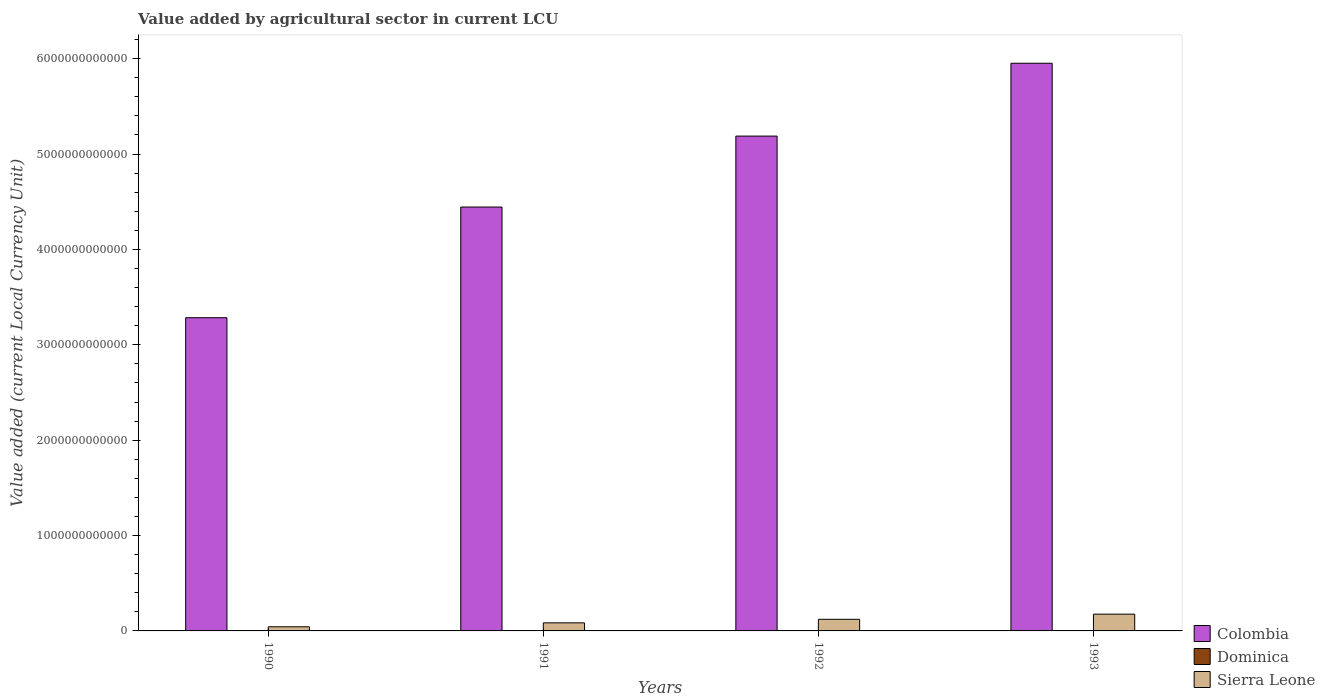How many different coloured bars are there?
Offer a terse response. 3. How many groups of bars are there?
Provide a succinct answer. 4. Are the number of bars per tick equal to the number of legend labels?
Keep it short and to the point. Yes. Are the number of bars on each tick of the X-axis equal?
Provide a short and direct response. Yes. What is the value added by agricultural sector in Sierra Leone in 1993?
Your response must be concise. 1.76e+11. Across all years, what is the maximum value added by agricultural sector in Dominica?
Provide a short and direct response. 9.80e+07. Across all years, what is the minimum value added by agricultural sector in Dominica?
Provide a short and direct response. 9.25e+07. In which year was the value added by agricultural sector in Sierra Leone minimum?
Your answer should be very brief. 1990. What is the total value added by agricultural sector in Colombia in the graph?
Provide a short and direct response. 1.89e+13. What is the difference between the value added by agricultural sector in Colombia in 1990 and that in 1992?
Provide a succinct answer. -1.90e+12. What is the difference between the value added by agricultural sector in Sierra Leone in 1993 and the value added by agricultural sector in Dominica in 1990?
Offer a terse response. 1.76e+11. What is the average value added by agricultural sector in Sierra Leone per year?
Make the answer very short. 1.06e+11. In the year 1991, what is the difference between the value added by agricultural sector in Colombia and value added by agricultural sector in Sierra Leone?
Provide a short and direct response. 4.36e+12. What is the ratio of the value added by agricultural sector in Dominica in 1991 to that in 1993?
Your response must be concise. 0.99. What is the difference between the highest and the lowest value added by agricultural sector in Sierra Leone?
Give a very brief answer. 1.33e+11. What does the 2nd bar from the left in 1990 represents?
Ensure brevity in your answer.  Dominica. What does the 1st bar from the right in 1990 represents?
Offer a terse response. Sierra Leone. How many bars are there?
Keep it short and to the point. 12. Are all the bars in the graph horizontal?
Offer a terse response. No. What is the difference between two consecutive major ticks on the Y-axis?
Offer a terse response. 1.00e+12. Are the values on the major ticks of Y-axis written in scientific E-notation?
Make the answer very short. No. Does the graph contain any zero values?
Offer a terse response. No. Does the graph contain grids?
Ensure brevity in your answer.  No. Where does the legend appear in the graph?
Make the answer very short. Bottom right. How many legend labels are there?
Ensure brevity in your answer.  3. How are the legend labels stacked?
Make the answer very short. Vertical. What is the title of the graph?
Keep it short and to the point. Value added by agricultural sector in current LCU. Does "Malaysia" appear as one of the legend labels in the graph?
Provide a short and direct response. No. What is the label or title of the Y-axis?
Offer a very short reply. Value added (current Local Currency Unit). What is the Value added (current Local Currency Unit) in Colombia in 1990?
Provide a short and direct response. 3.28e+12. What is the Value added (current Local Currency Unit) in Dominica in 1990?
Keep it short and to the point. 9.25e+07. What is the Value added (current Local Currency Unit) in Sierra Leone in 1990?
Give a very brief answer. 4.33e+1. What is the Value added (current Local Currency Unit) of Colombia in 1991?
Your answer should be compact. 4.44e+12. What is the Value added (current Local Currency Unit) of Dominica in 1991?
Provide a short and direct response. 9.69e+07. What is the Value added (current Local Currency Unit) in Sierra Leone in 1991?
Make the answer very short. 8.46e+1. What is the Value added (current Local Currency Unit) in Colombia in 1992?
Your answer should be very brief. 5.19e+12. What is the Value added (current Local Currency Unit) of Dominica in 1992?
Your answer should be very brief. 9.76e+07. What is the Value added (current Local Currency Unit) of Sierra Leone in 1992?
Provide a short and direct response. 1.22e+11. What is the Value added (current Local Currency Unit) in Colombia in 1993?
Offer a very short reply. 5.95e+12. What is the Value added (current Local Currency Unit) in Dominica in 1993?
Offer a terse response. 9.80e+07. What is the Value added (current Local Currency Unit) of Sierra Leone in 1993?
Provide a short and direct response. 1.76e+11. Across all years, what is the maximum Value added (current Local Currency Unit) of Colombia?
Make the answer very short. 5.95e+12. Across all years, what is the maximum Value added (current Local Currency Unit) of Dominica?
Your response must be concise. 9.80e+07. Across all years, what is the maximum Value added (current Local Currency Unit) in Sierra Leone?
Give a very brief answer. 1.76e+11. Across all years, what is the minimum Value added (current Local Currency Unit) in Colombia?
Make the answer very short. 3.28e+12. Across all years, what is the minimum Value added (current Local Currency Unit) in Dominica?
Keep it short and to the point. 9.25e+07. Across all years, what is the minimum Value added (current Local Currency Unit) in Sierra Leone?
Your answer should be very brief. 4.33e+1. What is the total Value added (current Local Currency Unit) of Colombia in the graph?
Offer a terse response. 1.89e+13. What is the total Value added (current Local Currency Unit) of Dominica in the graph?
Offer a terse response. 3.85e+08. What is the total Value added (current Local Currency Unit) of Sierra Leone in the graph?
Your answer should be compact. 4.26e+11. What is the difference between the Value added (current Local Currency Unit) in Colombia in 1990 and that in 1991?
Make the answer very short. -1.16e+12. What is the difference between the Value added (current Local Currency Unit) in Dominica in 1990 and that in 1991?
Offer a terse response. -4.42e+06. What is the difference between the Value added (current Local Currency Unit) of Sierra Leone in 1990 and that in 1991?
Provide a short and direct response. -4.13e+1. What is the difference between the Value added (current Local Currency Unit) in Colombia in 1990 and that in 1992?
Your answer should be compact. -1.90e+12. What is the difference between the Value added (current Local Currency Unit) in Dominica in 1990 and that in 1992?
Keep it short and to the point. -5.13e+06. What is the difference between the Value added (current Local Currency Unit) in Sierra Leone in 1990 and that in 1992?
Provide a succinct answer. -7.86e+1. What is the difference between the Value added (current Local Currency Unit) in Colombia in 1990 and that in 1993?
Provide a succinct answer. -2.67e+12. What is the difference between the Value added (current Local Currency Unit) in Dominica in 1990 and that in 1993?
Ensure brevity in your answer.  -5.52e+06. What is the difference between the Value added (current Local Currency Unit) in Sierra Leone in 1990 and that in 1993?
Give a very brief answer. -1.33e+11. What is the difference between the Value added (current Local Currency Unit) of Colombia in 1991 and that in 1992?
Keep it short and to the point. -7.44e+11. What is the difference between the Value added (current Local Currency Unit) in Dominica in 1991 and that in 1992?
Your answer should be compact. -7.10e+05. What is the difference between the Value added (current Local Currency Unit) of Sierra Leone in 1991 and that in 1992?
Ensure brevity in your answer.  -3.72e+1. What is the difference between the Value added (current Local Currency Unit) of Colombia in 1991 and that in 1993?
Provide a succinct answer. -1.51e+12. What is the difference between the Value added (current Local Currency Unit) in Dominica in 1991 and that in 1993?
Make the answer very short. -1.10e+06. What is the difference between the Value added (current Local Currency Unit) in Sierra Leone in 1991 and that in 1993?
Ensure brevity in your answer.  -9.12e+1. What is the difference between the Value added (current Local Currency Unit) in Colombia in 1992 and that in 1993?
Offer a very short reply. -7.64e+11. What is the difference between the Value added (current Local Currency Unit) in Dominica in 1992 and that in 1993?
Your answer should be compact. -3.90e+05. What is the difference between the Value added (current Local Currency Unit) in Sierra Leone in 1992 and that in 1993?
Offer a very short reply. -5.40e+1. What is the difference between the Value added (current Local Currency Unit) in Colombia in 1990 and the Value added (current Local Currency Unit) in Dominica in 1991?
Provide a succinct answer. 3.28e+12. What is the difference between the Value added (current Local Currency Unit) of Colombia in 1990 and the Value added (current Local Currency Unit) of Sierra Leone in 1991?
Your response must be concise. 3.20e+12. What is the difference between the Value added (current Local Currency Unit) of Dominica in 1990 and the Value added (current Local Currency Unit) of Sierra Leone in 1991?
Offer a terse response. -8.46e+1. What is the difference between the Value added (current Local Currency Unit) in Colombia in 1990 and the Value added (current Local Currency Unit) in Dominica in 1992?
Keep it short and to the point. 3.28e+12. What is the difference between the Value added (current Local Currency Unit) of Colombia in 1990 and the Value added (current Local Currency Unit) of Sierra Leone in 1992?
Make the answer very short. 3.16e+12. What is the difference between the Value added (current Local Currency Unit) in Dominica in 1990 and the Value added (current Local Currency Unit) in Sierra Leone in 1992?
Provide a short and direct response. -1.22e+11. What is the difference between the Value added (current Local Currency Unit) in Colombia in 1990 and the Value added (current Local Currency Unit) in Dominica in 1993?
Your answer should be very brief. 3.28e+12. What is the difference between the Value added (current Local Currency Unit) of Colombia in 1990 and the Value added (current Local Currency Unit) of Sierra Leone in 1993?
Make the answer very short. 3.11e+12. What is the difference between the Value added (current Local Currency Unit) of Dominica in 1990 and the Value added (current Local Currency Unit) of Sierra Leone in 1993?
Your answer should be very brief. -1.76e+11. What is the difference between the Value added (current Local Currency Unit) of Colombia in 1991 and the Value added (current Local Currency Unit) of Dominica in 1992?
Your answer should be compact. 4.44e+12. What is the difference between the Value added (current Local Currency Unit) in Colombia in 1991 and the Value added (current Local Currency Unit) in Sierra Leone in 1992?
Keep it short and to the point. 4.32e+12. What is the difference between the Value added (current Local Currency Unit) in Dominica in 1991 and the Value added (current Local Currency Unit) in Sierra Leone in 1992?
Your response must be concise. -1.22e+11. What is the difference between the Value added (current Local Currency Unit) of Colombia in 1991 and the Value added (current Local Currency Unit) of Dominica in 1993?
Ensure brevity in your answer.  4.44e+12. What is the difference between the Value added (current Local Currency Unit) in Colombia in 1991 and the Value added (current Local Currency Unit) in Sierra Leone in 1993?
Your answer should be very brief. 4.27e+12. What is the difference between the Value added (current Local Currency Unit) in Dominica in 1991 and the Value added (current Local Currency Unit) in Sierra Leone in 1993?
Your answer should be very brief. -1.76e+11. What is the difference between the Value added (current Local Currency Unit) in Colombia in 1992 and the Value added (current Local Currency Unit) in Dominica in 1993?
Your response must be concise. 5.19e+12. What is the difference between the Value added (current Local Currency Unit) in Colombia in 1992 and the Value added (current Local Currency Unit) in Sierra Leone in 1993?
Your answer should be compact. 5.01e+12. What is the difference between the Value added (current Local Currency Unit) in Dominica in 1992 and the Value added (current Local Currency Unit) in Sierra Leone in 1993?
Provide a short and direct response. -1.76e+11. What is the average Value added (current Local Currency Unit) of Colombia per year?
Provide a succinct answer. 4.72e+12. What is the average Value added (current Local Currency Unit) of Dominica per year?
Make the answer very short. 9.63e+07. What is the average Value added (current Local Currency Unit) of Sierra Leone per year?
Give a very brief answer. 1.06e+11. In the year 1990, what is the difference between the Value added (current Local Currency Unit) of Colombia and Value added (current Local Currency Unit) of Dominica?
Make the answer very short. 3.28e+12. In the year 1990, what is the difference between the Value added (current Local Currency Unit) of Colombia and Value added (current Local Currency Unit) of Sierra Leone?
Provide a short and direct response. 3.24e+12. In the year 1990, what is the difference between the Value added (current Local Currency Unit) in Dominica and Value added (current Local Currency Unit) in Sierra Leone?
Offer a very short reply. -4.32e+1. In the year 1991, what is the difference between the Value added (current Local Currency Unit) in Colombia and Value added (current Local Currency Unit) in Dominica?
Provide a succinct answer. 4.44e+12. In the year 1991, what is the difference between the Value added (current Local Currency Unit) of Colombia and Value added (current Local Currency Unit) of Sierra Leone?
Keep it short and to the point. 4.36e+12. In the year 1991, what is the difference between the Value added (current Local Currency Unit) of Dominica and Value added (current Local Currency Unit) of Sierra Leone?
Offer a terse response. -8.46e+1. In the year 1992, what is the difference between the Value added (current Local Currency Unit) in Colombia and Value added (current Local Currency Unit) in Dominica?
Ensure brevity in your answer.  5.19e+12. In the year 1992, what is the difference between the Value added (current Local Currency Unit) of Colombia and Value added (current Local Currency Unit) of Sierra Leone?
Provide a short and direct response. 5.07e+12. In the year 1992, what is the difference between the Value added (current Local Currency Unit) of Dominica and Value added (current Local Currency Unit) of Sierra Leone?
Make the answer very short. -1.22e+11. In the year 1993, what is the difference between the Value added (current Local Currency Unit) of Colombia and Value added (current Local Currency Unit) of Dominica?
Your answer should be very brief. 5.95e+12. In the year 1993, what is the difference between the Value added (current Local Currency Unit) of Colombia and Value added (current Local Currency Unit) of Sierra Leone?
Your answer should be very brief. 5.78e+12. In the year 1993, what is the difference between the Value added (current Local Currency Unit) in Dominica and Value added (current Local Currency Unit) in Sierra Leone?
Your answer should be very brief. -1.76e+11. What is the ratio of the Value added (current Local Currency Unit) of Colombia in 1990 to that in 1991?
Ensure brevity in your answer.  0.74. What is the ratio of the Value added (current Local Currency Unit) in Dominica in 1990 to that in 1991?
Offer a very short reply. 0.95. What is the ratio of the Value added (current Local Currency Unit) in Sierra Leone in 1990 to that in 1991?
Offer a terse response. 0.51. What is the ratio of the Value added (current Local Currency Unit) in Colombia in 1990 to that in 1992?
Offer a very short reply. 0.63. What is the ratio of the Value added (current Local Currency Unit) in Dominica in 1990 to that in 1992?
Your answer should be very brief. 0.95. What is the ratio of the Value added (current Local Currency Unit) in Sierra Leone in 1990 to that in 1992?
Keep it short and to the point. 0.36. What is the ratio of the Value added (current Local Currency Unit) of Colombia in 1990 to that in 1993?
Provide a succinct answer. 0.55. What is the ratio of the Value added (current Local Currency Unit) in Dominica in 1990 to that in 1993?
Your answer should be compact. 0.94. What is the ratio of the Value added (current Local Currency Unit) of Sierra Leone in 1990 to that in 1993?
Offer a terse response. 0.25. What is the ratio of the Value added (current Local Currency Unit) in Colombia in 1991 to that in 1992?
Ensure brevity in your answer.  0.86. What is the ratio of the Value added (current Local Currency Unit) in Dominica in 1991 to that in 1992?
Your answer should be compact. 0.99. What is the ratio of the Value added (current Local Currency Unit) of Sierra Leone in 1991 to that in 1992?
Make the answer very short. 0.69. What is the ratio of the Value added (current Local Currency Unit) in Colombia in 1991 to that in 1993?
Your answer should be very brief. 0.75. What is the ratio of the Value added (current Local Currency Unit) of Dominica in 1991 to that in 1993?
Offer a very short reply. 0.99. What is the ratio of the Value added (current Local Currency Unit) of Sierra Leone in 1991 to that in 1993?
Make the answer very short. 0.48. What is the ratio of the Value added (current Local Currency Unit) of Colombia in 1992 to that in 1993?
Your response must be concise. 0.87. What is the ratio of the Value added (current Local Currency Unit) of Dominica in 1992 to that in 1993?
Offer a very short reply. 1. What is the ratio of the Value added (current Local Currency Unit) in Sierra Leone in 1992 to that in 1993?
Offer a terse response. 0.69. What is the difference between the highest and the second highest Value added (current Local Currency Unit) in Colombia?
Provide a succinct answer. 7.64e+11. What is the difference between the highest and the second highest Value added (current Local Currency Unit) of Dominica?
Make the answer very short. 3.90e+05. What is the difference between the highest and the second highest Value added (current Local Currency Unit) of Sierra Leone?
Your response must be concise. 5.40e+1. What is the difference between the highest and the lowest Value added (current Local Currency Unit) of Colombia?
Offer a terse response. 2.67e+12. What is the difference between the highest and the lowest Value added (current Local Currency Unit) of Dominica?
Offer a very short reply. 5.52e+06. What is the difference between the highest and the lowest Value added (current Local Currency Unit) of Sierra Leone?
Provide a succinct answer. 1.33e+11. 